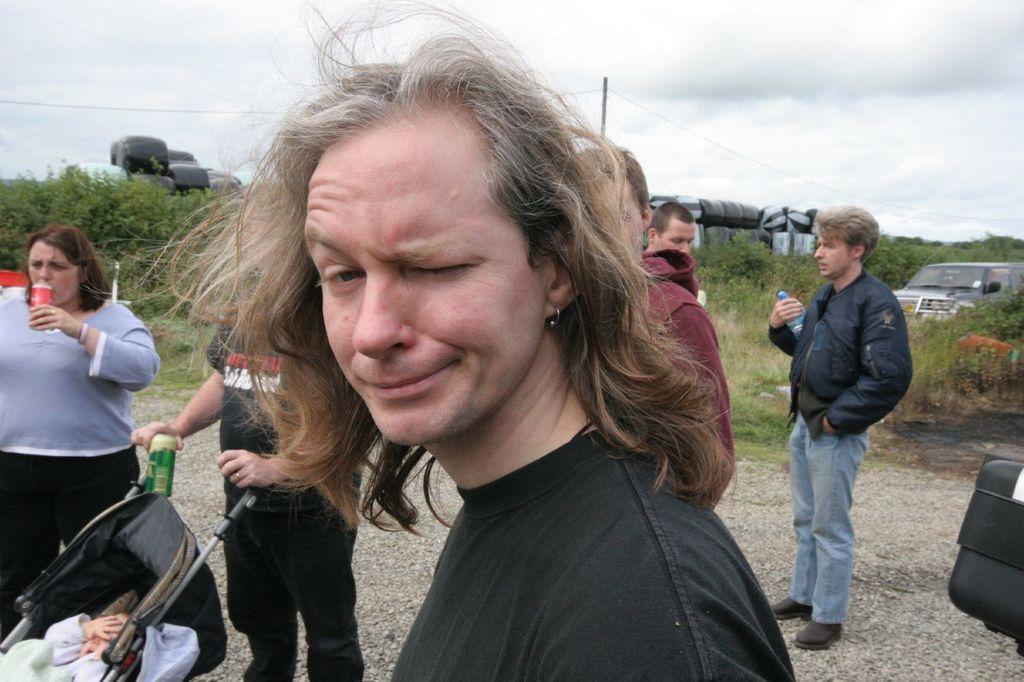In one or two sentences, can you explain what this image depicts? In this image we can see a group of people standing on the ground. On the left side of the image we can see a baby inside the baby carrier. On the right side, we can see a person holding a bottle. In the background, we can see a vehicle parked on the ground, some objects placed on the ground, a group of trees, pole with a cable and the cloudy sky. 